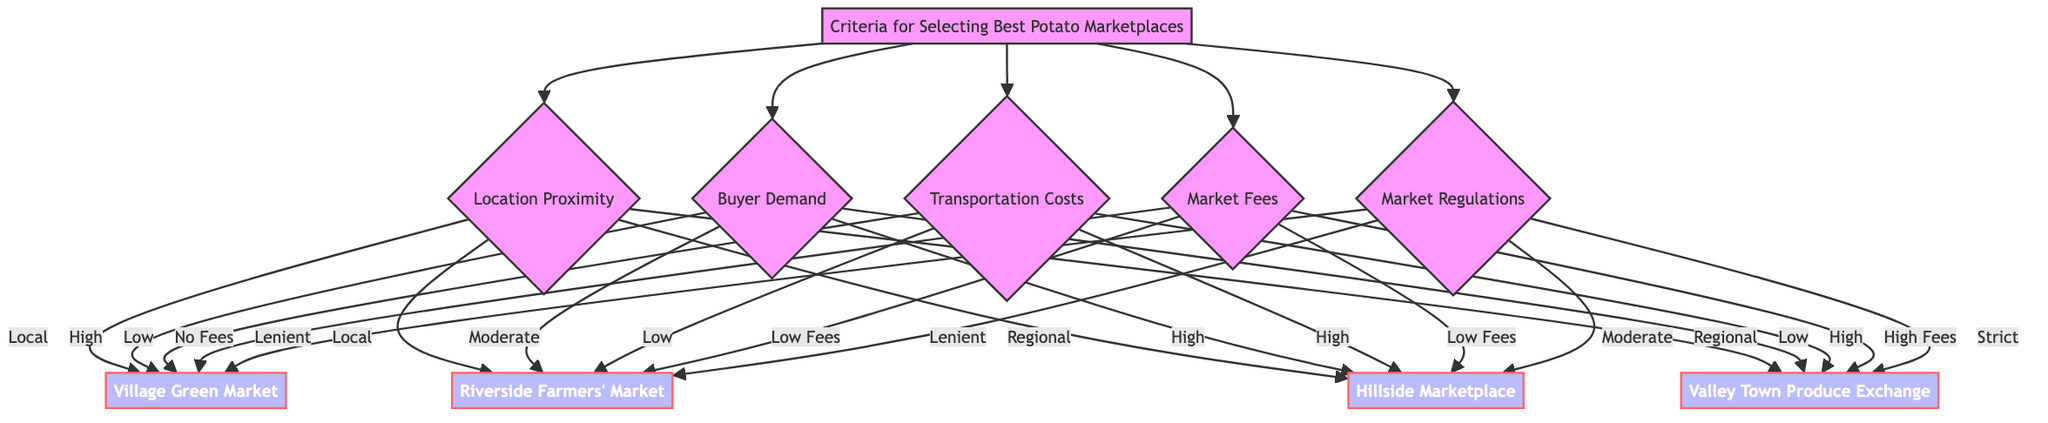What marketplaces are categorized under Local Markets? The diagram shows that the Local Markets include Village Green Market and Riverside Farmers' Market, which are directly linked under the Location Proximity node labeled "Local".
Answer: Village Green Market, Riverside Farmers' Market Which marketplace has No Fees? The diagram indicates that the Village Green Market is the only marketplace listed under the Market Fees node with "No Fees".
Answer: Village Green Market What is the Buyer Demand classification for Riverside Farmers' Market? To find the Buyer Demand classification for Riverside Farmers' Market, I look under the Buyer Demand node. It is shown as "Moderate Demand".
Answer: Moderate Demand Which marketplaces have High Demand? By navigating from the Buyer Demand node, I can identify that both Village Green Market and Hillside Marketplace are listed under "High Demand".
Answer: Village Green Market, Hillside Marketplace Which marketplace has Strict Regulations? The diagram specifies that the Valley Town Produce Exchange falls under the Market Regulations node labeled "Strict Regulations".
Answer: Valley Town Produce Exchange What criteria separate the Village Green Market from the Valley Town Produce Exchange? To determine the differences, I analyze multiple criteria. The Village Green Market has No Fees, Low Transportation Costs, Lenient Regulations, and High Demand, while the Valley Town Produce Exchange has High Fees, High Transportation Costs, Strict Regulations, and Low Demand.
Answer: Fees, Transportation Costs, Regulations, Demand How many marketplaces are designated under Regional Markets? The Regional Markets category within the Location Proximity node includes two marketplaces: Hillside Marketplace and Valley Town Produce Exchange, leading to a count of two.
Answer: 2 What are the criteria for Low Transportation Costs? Low Transportation Costs encompass Village Green Market and Riverside Farmers' Market, both of which are linked under the Transportation Costs node showing "Low Costs".
Answer: Village Green Market, Riverside Farmers' Market Which marketplace has both Low Fees and Lenient Regulations? The Riverside Farmers' Market is uniquely linked under both the Market Fees node labeled "Low Fees" and the Market Regulations node labeled "Lenient Regulations", satisfying both criteria.
Answer: Riverside Farmers' Market 